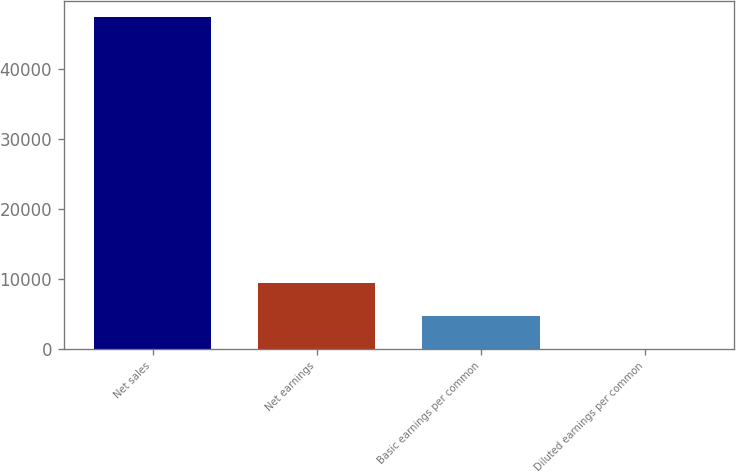Convert chart to OTSL. <chart><loc_0><loc_0><loc_500><loc_500><bar_chart><fcel>Net sales<fcel>Net earnings<fcel>Basic earnings per common<fcel>Diluted earnings per common<nl><fcel>47369<fcel>9482.42<fcel>4746.6<fcel>10.78<nl></chart> 